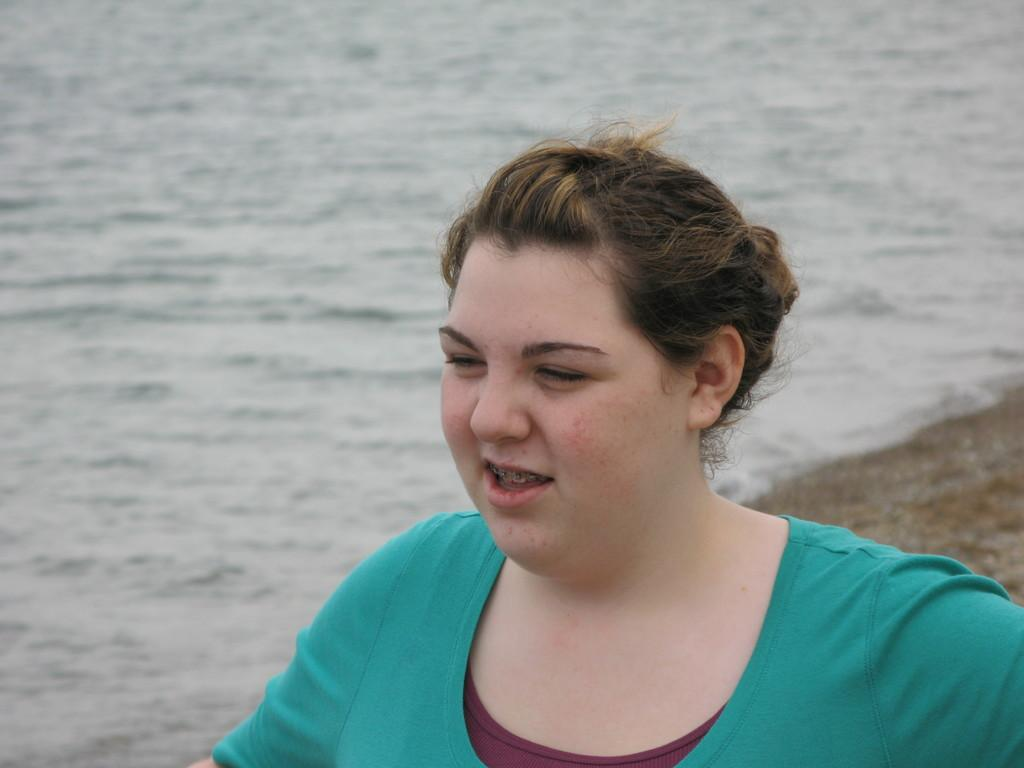Who or what is the main subject in the image? There is a person in the image. What is the person wearing? The person is wearing a green and brown color dress. What type of environment is visible in the background of the image? There is sand and water visible in the background of the image. What type of hospital can be seen in the background of the image? There is no hospital present in the image; it features a person in a green and brown dress with a sand and water background. How many legs does the person have in the image? The person in the image has two legs, but this information cannot be determined from the image alone, as it only shows the person from the waist up. 